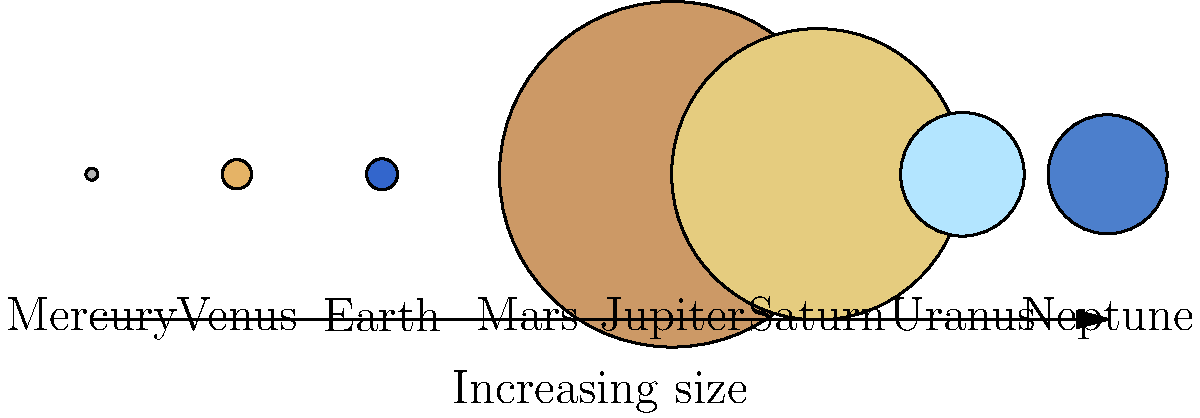As a landscape artist inspired by geological features, you're exploring the concept of planetary landscapes. Which planet in our solar system would offer the most expansive vistas for your artwork, considering its size relative to Earth? To answer this question, we need to compare the relative sizes of the planets in our solar system:

1. First, let's identify the sizes of the planets relative to Earth:
   Mercury: 0.38 × Earth
   Venus: 0.95 × Earth
   Earth: 1 × Earth
   Mars: 0.53 × Earth
   Jupiter: 11.2 × Earth
   Saturn: 9.4 × Earth
   Uranus: 4.0 × Earth
   Neptune: 3.9 × Earth

2. The largest planet is Jupiter, with a diameter 11.2 times that of Earth.

3. A larger planet would have a larger surface area, which is proportional to the square of its diameter. Jupiter's surface area would be approximately $11.2^2 = 125.44$ times that of Earth.

4. This vast surface area would provide the most expansive landscapes and vistas for artistic inspiration.

5. Jupiter's diverse atmospheric features, such as the Great Red Spot and numerous storm systems, would offer unique and grand-scale geological inspirations, albeit in a gaseous form.

6. While Saturn is the second-largest planet, its most distinctive feature (the rings) is not part of its landscape. Jupiter's sheer size and atmospheric dynamics make it the best choice for expansive vistas.
Answer: Jupiter 